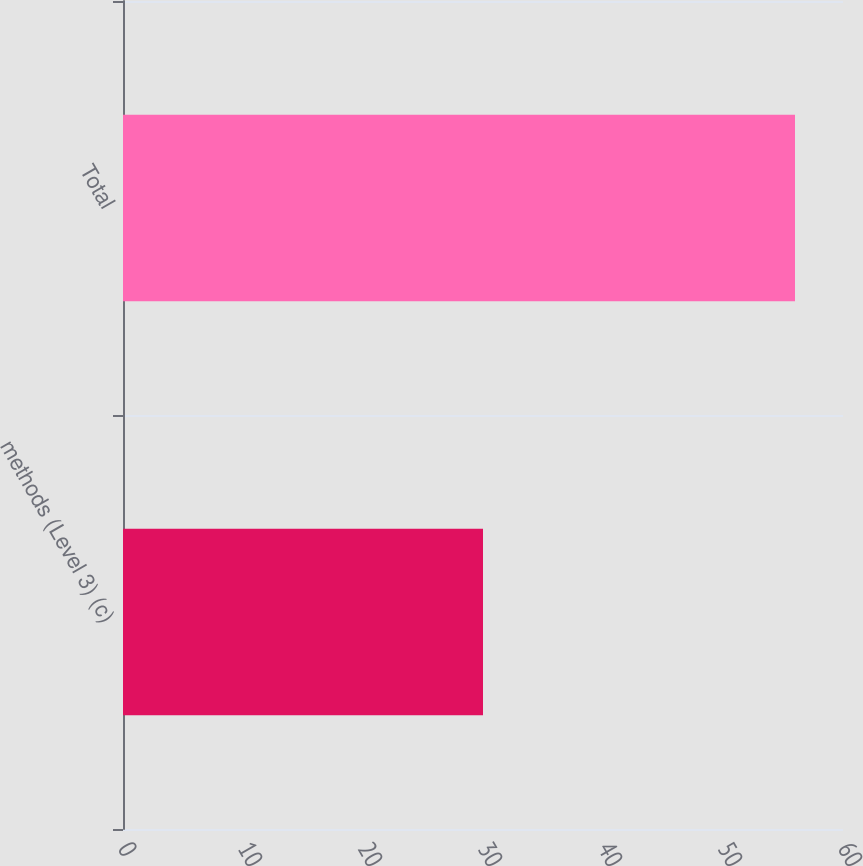Convert chart to OTSL. <chart><loc_0><loc_0><loc_500><loc_500><bar_chart><fcel>methods (Level 3) (c)<fcel>Total<nl><fcel>30<fcel>56<nl></chart> 